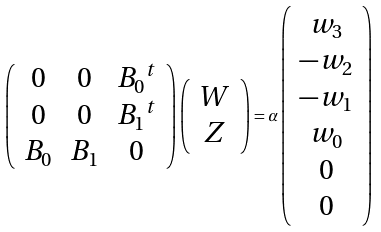Convert formula to latex. <formula><loc_0><loc_0><loc_500><loc_500>\left ( \begin{array} { c c c } 0 & 0 & { B _ { 0 } } ^ { t } \\ 0 & 0 & { B _ { 1 } } ^ { t } \\ B _ { 0 } & B _ { 1 } & 0 \end{array} \right ) \left ( \begin{array} { c } W \\ Z \end{array} \right ) = \alpha \left ( \begin{array} { c } w _ { 3 } \\ - w _ { 2 } \\ - w _ { 1 } \\ w _ { 0 } \\ 0 \\ 0 \end{array} \right )</formula> 